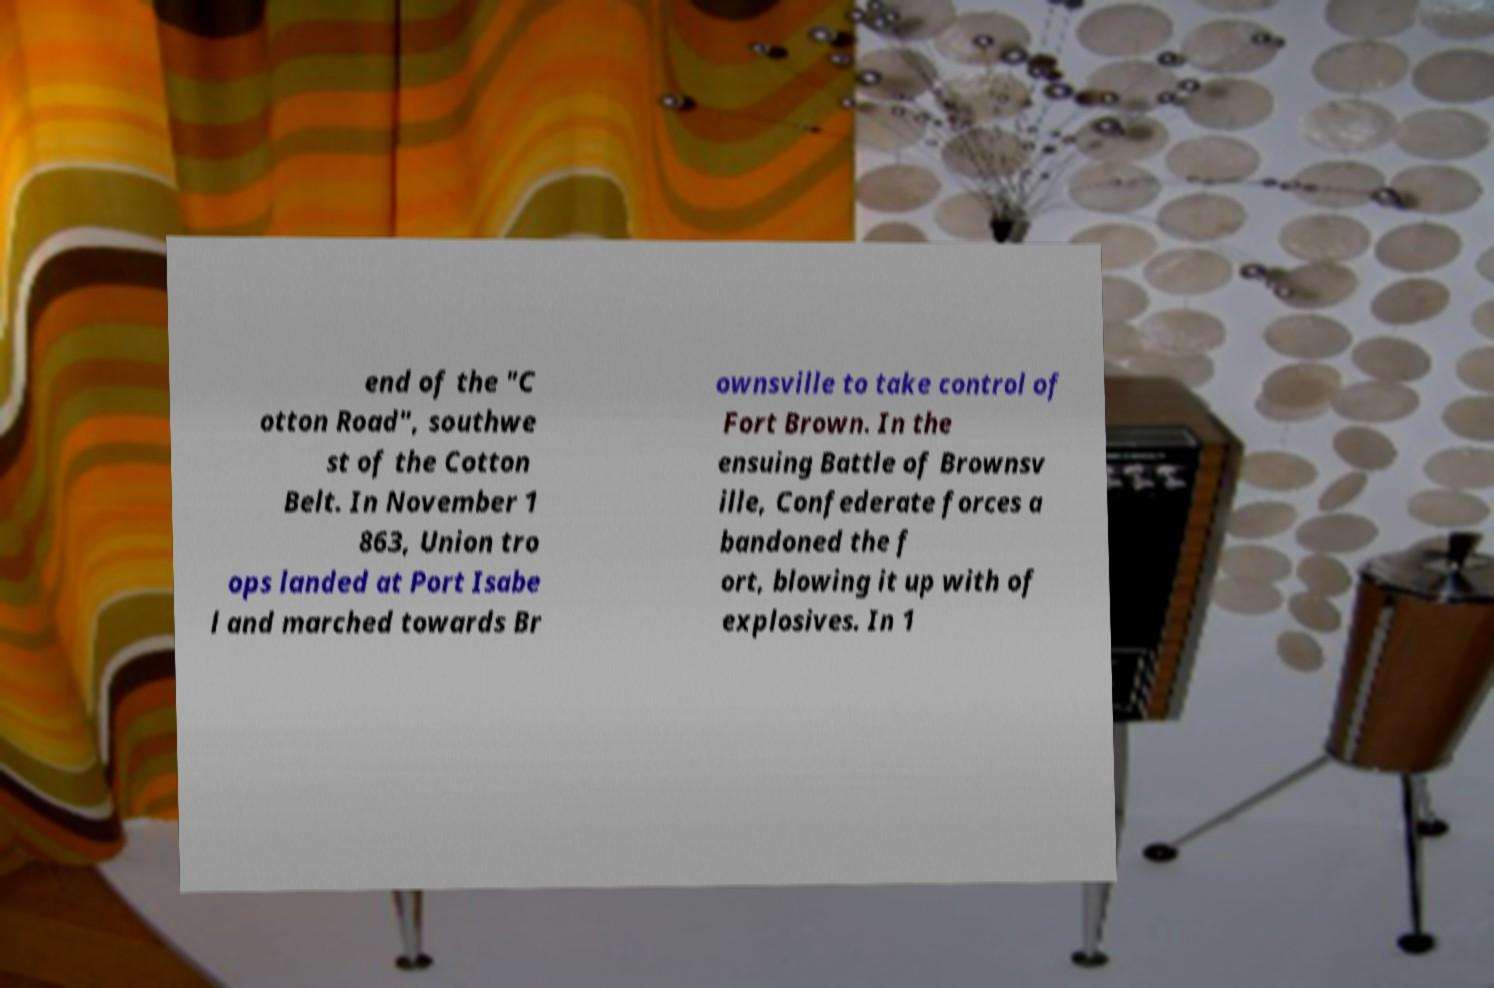Please read and relay the text visible in this image. What does it say? end of the "C otton Road", southwe st of the Cotton Belt. In November 1 863, Union tro ops landed at Port Isabe l and marched towards Br ownsville to take control of Fort Brown. In the ensuing Battle of Brownsv ille, Confederate forces a bandoned the f ort, blowing it up with of explosives. In 1 